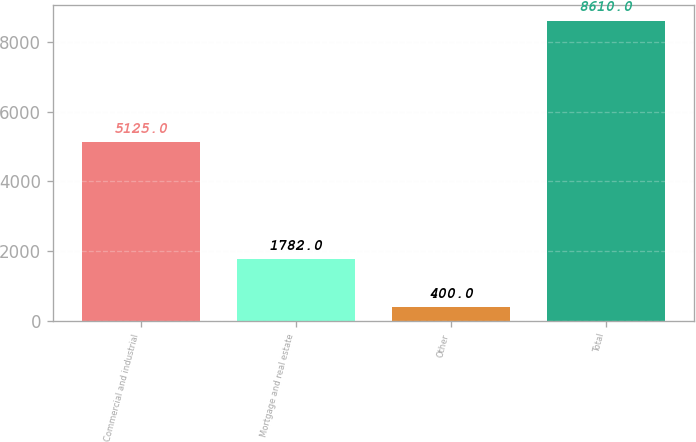<chart> <loc_0><loc_0><loc_500><loc_500><bar_chart><fcel>Commercial and industrial<fcel>Mortgage and real estate<fcel>Other<fcel>Total<nl><fcel>5125<fcel>1782<fcel>400<fcel>8610<nl></chart> 